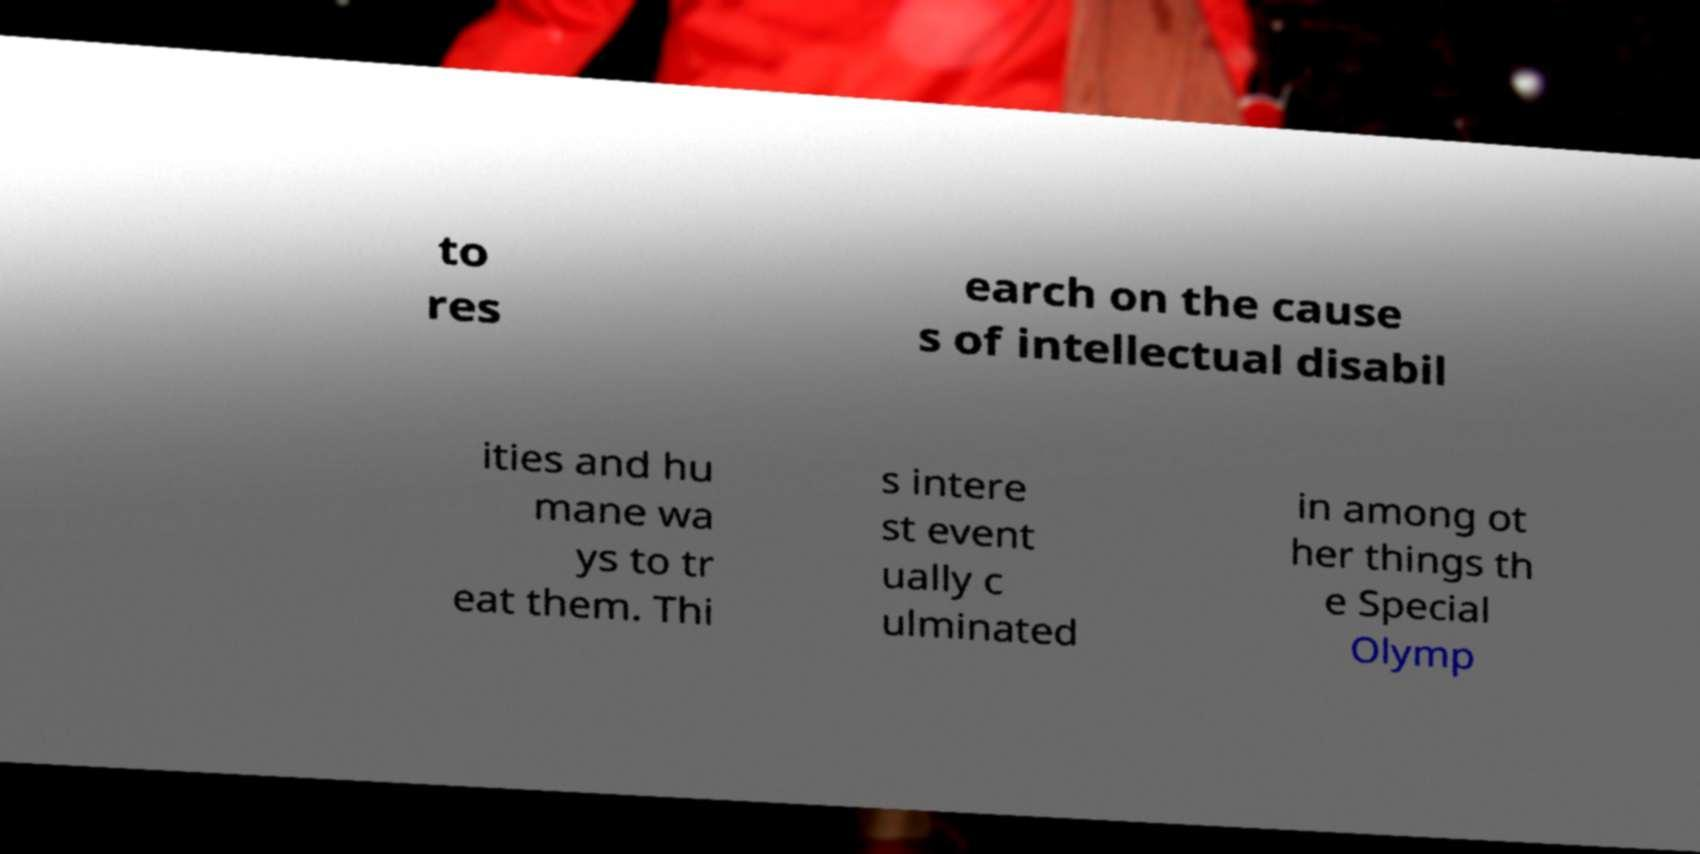Could you assist in decoding the text presented in this image and type it out clearly? to res earch on the cause s of intellectual disabil ities and hu mane wa ys to tr eat them. Thi s intere st event ually c ulminated in among ot her things th e Special Olymp 